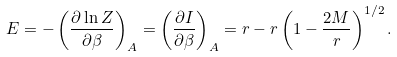Convert formula to latex. <formula><loc_0><loc_0><loc_500><loc_500>E = - \left ( \frac { \partial \ln Z } { \partial \beta } \right ) _ { A } = \left ( \frac { \partial I } { \partial \beta } \right ) _ { A } = r - r \left ( 1 - \frac { 2 M } { r } \right ) ^ { 1 / 2 } .</formula> 